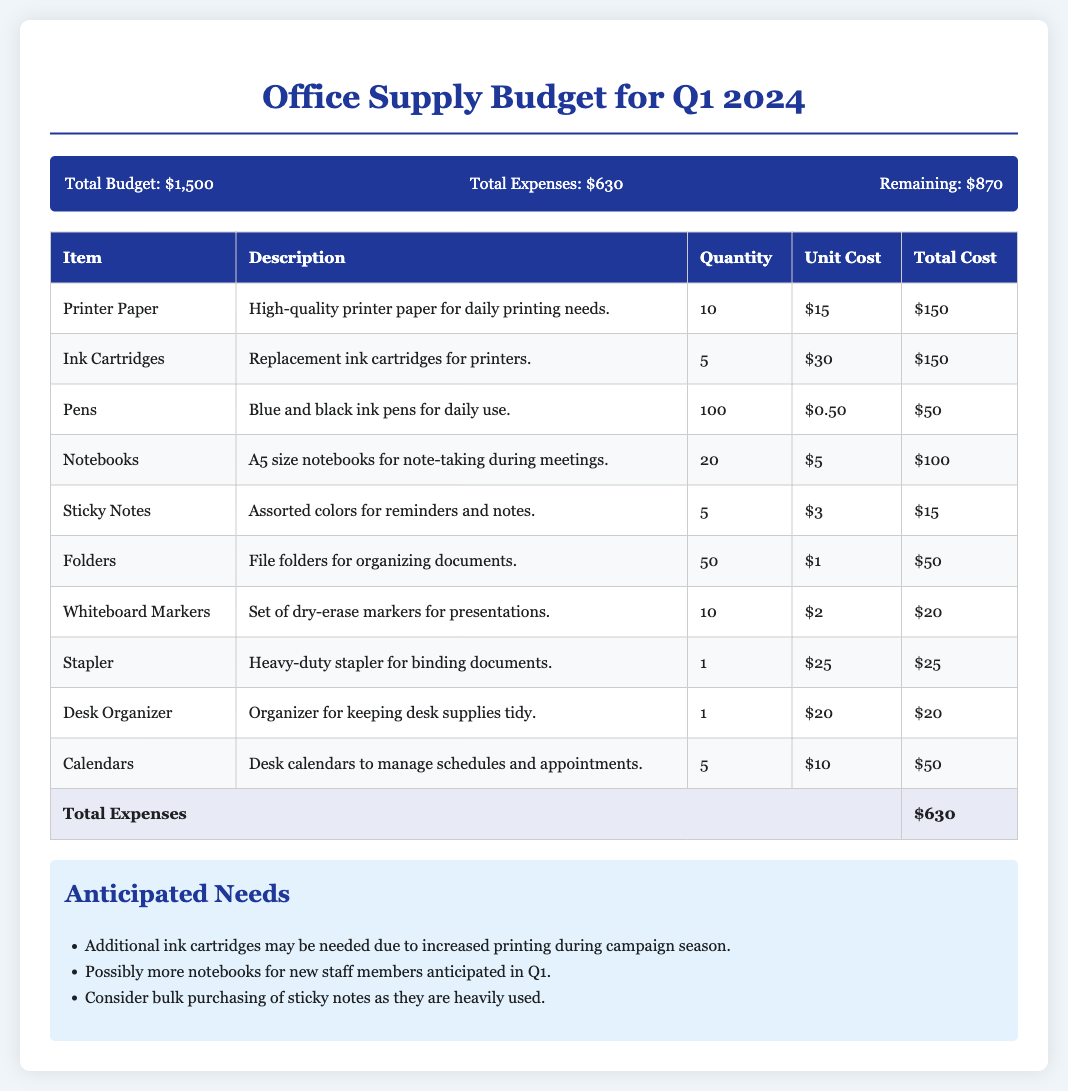What is the total budget? The total budget is stated at the beginning of the document.
Answer: $1,500 What is the total expense for the office supplies? The total expense is calculated based on the itemized list in the table.
Answer: $630 How many units of printer paper are included in the budget? The quantity of printer paper is clearly listed in the itemized expense table.
Answer: 10 What is the unit cost of ink cartridges? The unit cost of ink cartridges can be found in the table under unit cost.
Answer: $30 What are the anticipated needs concerning ink cartridges? The anticipated needs sections outlines possible future requirements for ink cartridges.
Answer: Additional ink cartridges How many folders are budgeted for purchase? The number of folders can be directly found in the itemized list of expenses.
Answer: 50 What is the total remaining budget after expenses? The remaining budget is calculated by subtracting total expenses from the total budget.
Answer: $870 What item has the highest unit cost in the budget? The item with the highest unit cost can be identified in the expense table.
Answer: Ink Cartridges What type of document is this? The document outlines financial allocations for office supplies, indicating its purpose.
Answer: Budget 